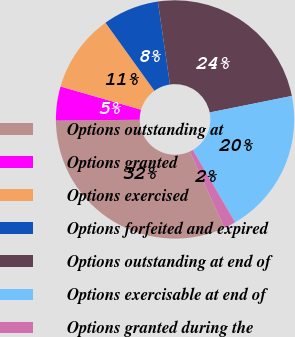<chart> <loc_0><loc_0><loc_500><loc_500><pie_chart><fcel>Options outstanding at<fcel>Options granted<fcel>Options exercised<fcel>Options forfeited and expired<fcel>Options outstanding at end of<fcel>Options exercisable at end of<fcel>Options granted during the<nl><fcel>31.66%<fcel>4.61%<fcel>10.62%<fcel>7.62%<fcel>24.14%<fcel>19.75%<fcel>1.6%<nl></chart> 